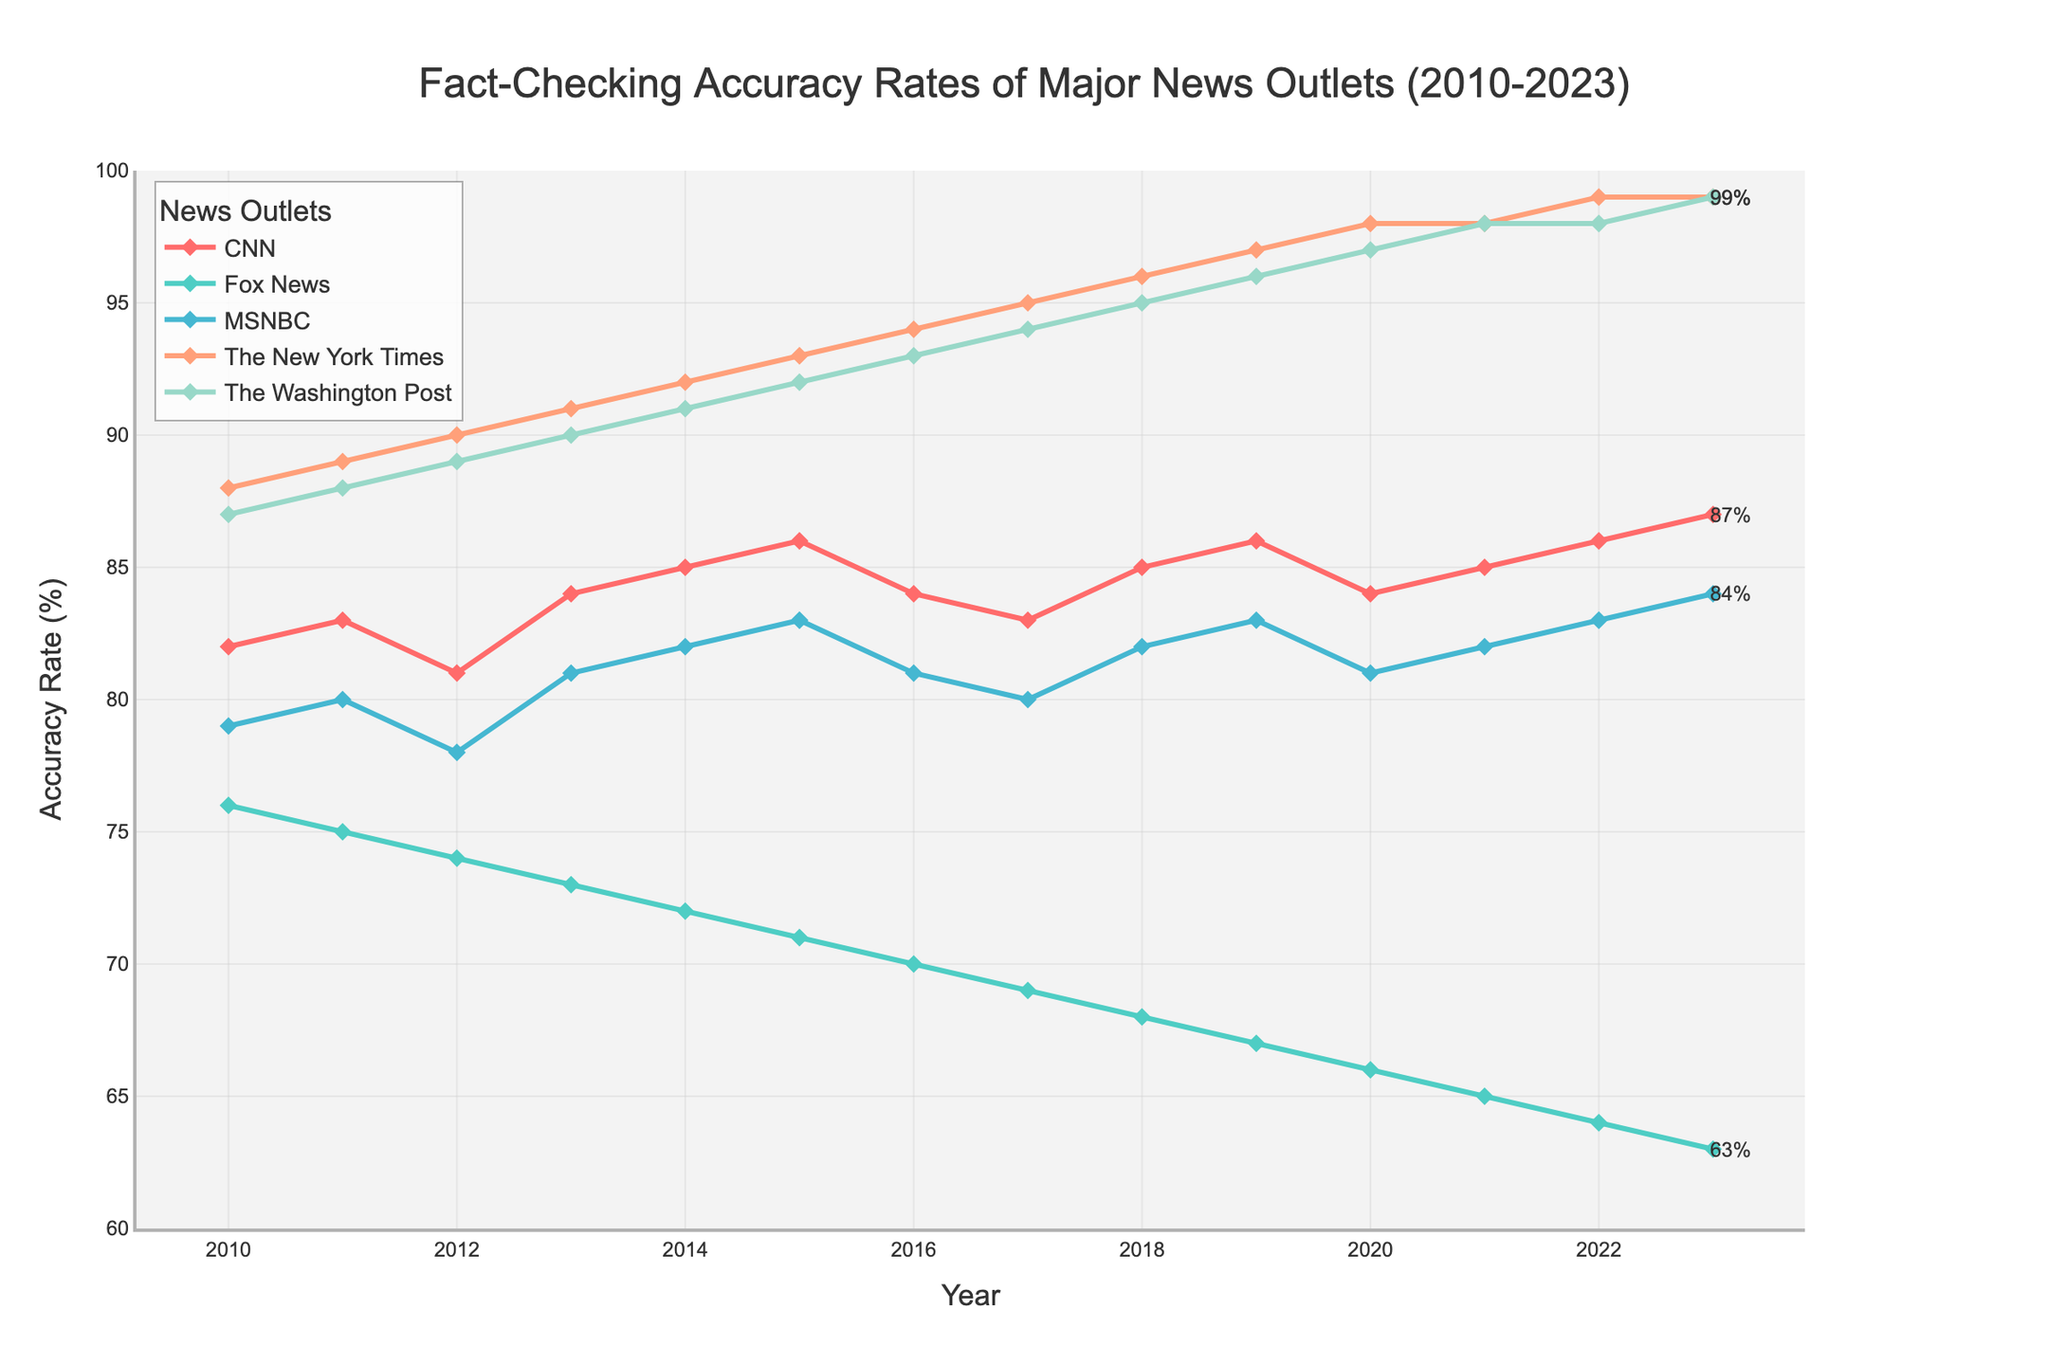What is the highest accuracy rate for The New York Times across the years? First, locate the line corresponding to The New York Times, which is represented in one of the provided colors. Next, identify the peak point on this line and note the corresponding accuracy rate value on the y-axis. The New York Times’ highest accuracy rate is reached in 2022 and 2023, where it peaks at 99%.
Answer: 99% Which news outlet had the lowest accuracy rate in 2023? Identify the line representing the year 2023 along the x-axis, and then find the lowest point among all the news outlet lines. This occurs where Fox News’ line dips to 63%.
Answer: Fox News Between 2010 and 2023, which year did CNN see the biggest increase in accuracy rate? Look for the points on the CNN line that represent the highest increase between two consecutive years. The largest increase is between 2022 and 2023, where the accuracy rate goes from 86% to 87%.
Answer: 2023 What is the average accuracy rate for MSNBC over the years? Extract the accuracy rates for MSNBC for each year from 2010 to 2023, then sum these values and divide by the number of years (14). The calculation is as follows: (79 + 80 + 78 + 81 + 82 + 83 + 81 + 80 + 82 + 83 + 81 + 82 + 83 + 84) / 14 = 81.
Answer: 81 Which two news outlets have the closest accuracy rates in 2010 and what are their rates? Check the accuracy rates of each news outlet in 2010. Identify pairs that are closest in value. The Washington Post and The New York Times have rates of 87% and 88%, respectively, making them the closest pair.
Answer: The Washington Post (87%) and The New York Times (88%) By how many percentage points did Fox News' accuracy rate decrease from 2010 to 2023? Subtract Fox News' accuracy rate in 2023 from its rate in 2010: 76% - 63% = 13 percentage points.
Answer: 13 Which news outlet shows the most consistent accuracy rate from 2010 to 2023, and what is the range of rates? Determine consistency by looking for the smallest range between the highest and lowest accuracy rates over the years for each outlet. The New York Times has the most consistent rates, with values ranging from 88% to 99%. The range is calculated as 99% - 88% = 11%.
Answer: The New York Times (11%) What is the combined accuracy rate of CNN and The Washington Post in 2015? Sum the accuracy rates of CNN and The Washington Post for 2015. CNN has an accuracy rate of 86%, and The Washington Post has 92%, so their combined total is 86% + 92% = 178%.
Answer: 178% Does any news outlet have an increasing trend in accuracy rate over the entire period from 2010 to 2023? Examine the line for each news outlet from 2010 to 2023 to see if it shows a general upward trajectory. The New York Times shows a clear increasing trend, starting from 88% in 2010 to 99% in 2023.
Answer: The New York Times What is the median accuracy rate for all news outlets in 2020? Collect the accuracy rates for all news outlets for the year 2020, and arrange them in ascending order: 66% (Fox News), 81% (CNN), 81% (MSNBC), 97% (The Washington Post), 98% (The New York Times). The median value is the middle one, which is 81%.
Answer: 81% 